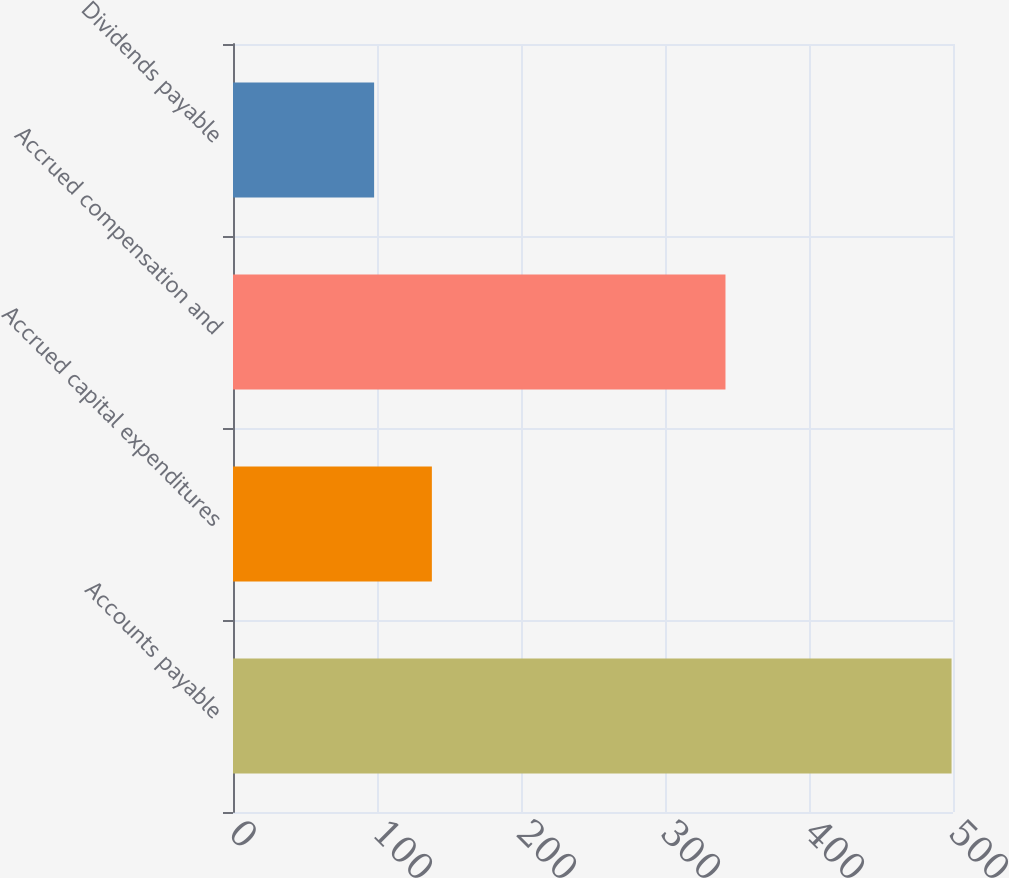Convert chart. <chart><loc_0><loc_0><loc_500><loc_500><bar_chart><fcel>Accounts payable<fcel>Accrued capital expenditures<fcel>Accrued compensation and<fcel>Dividends payable<nl><fcel>499<fcel>138.1<fcel>342<fcel>98<nl></chart> 